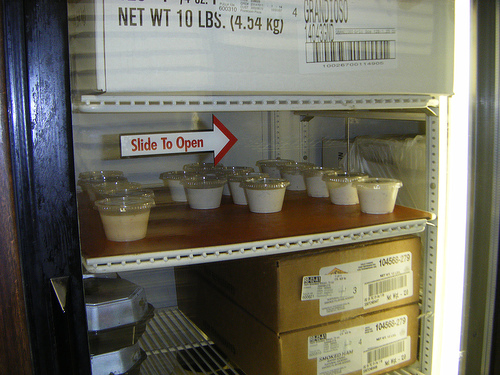<image>
Is the box in the refridgerator? Yes. The box is contained within or inside the refridgerator, showing a containment relationship. 